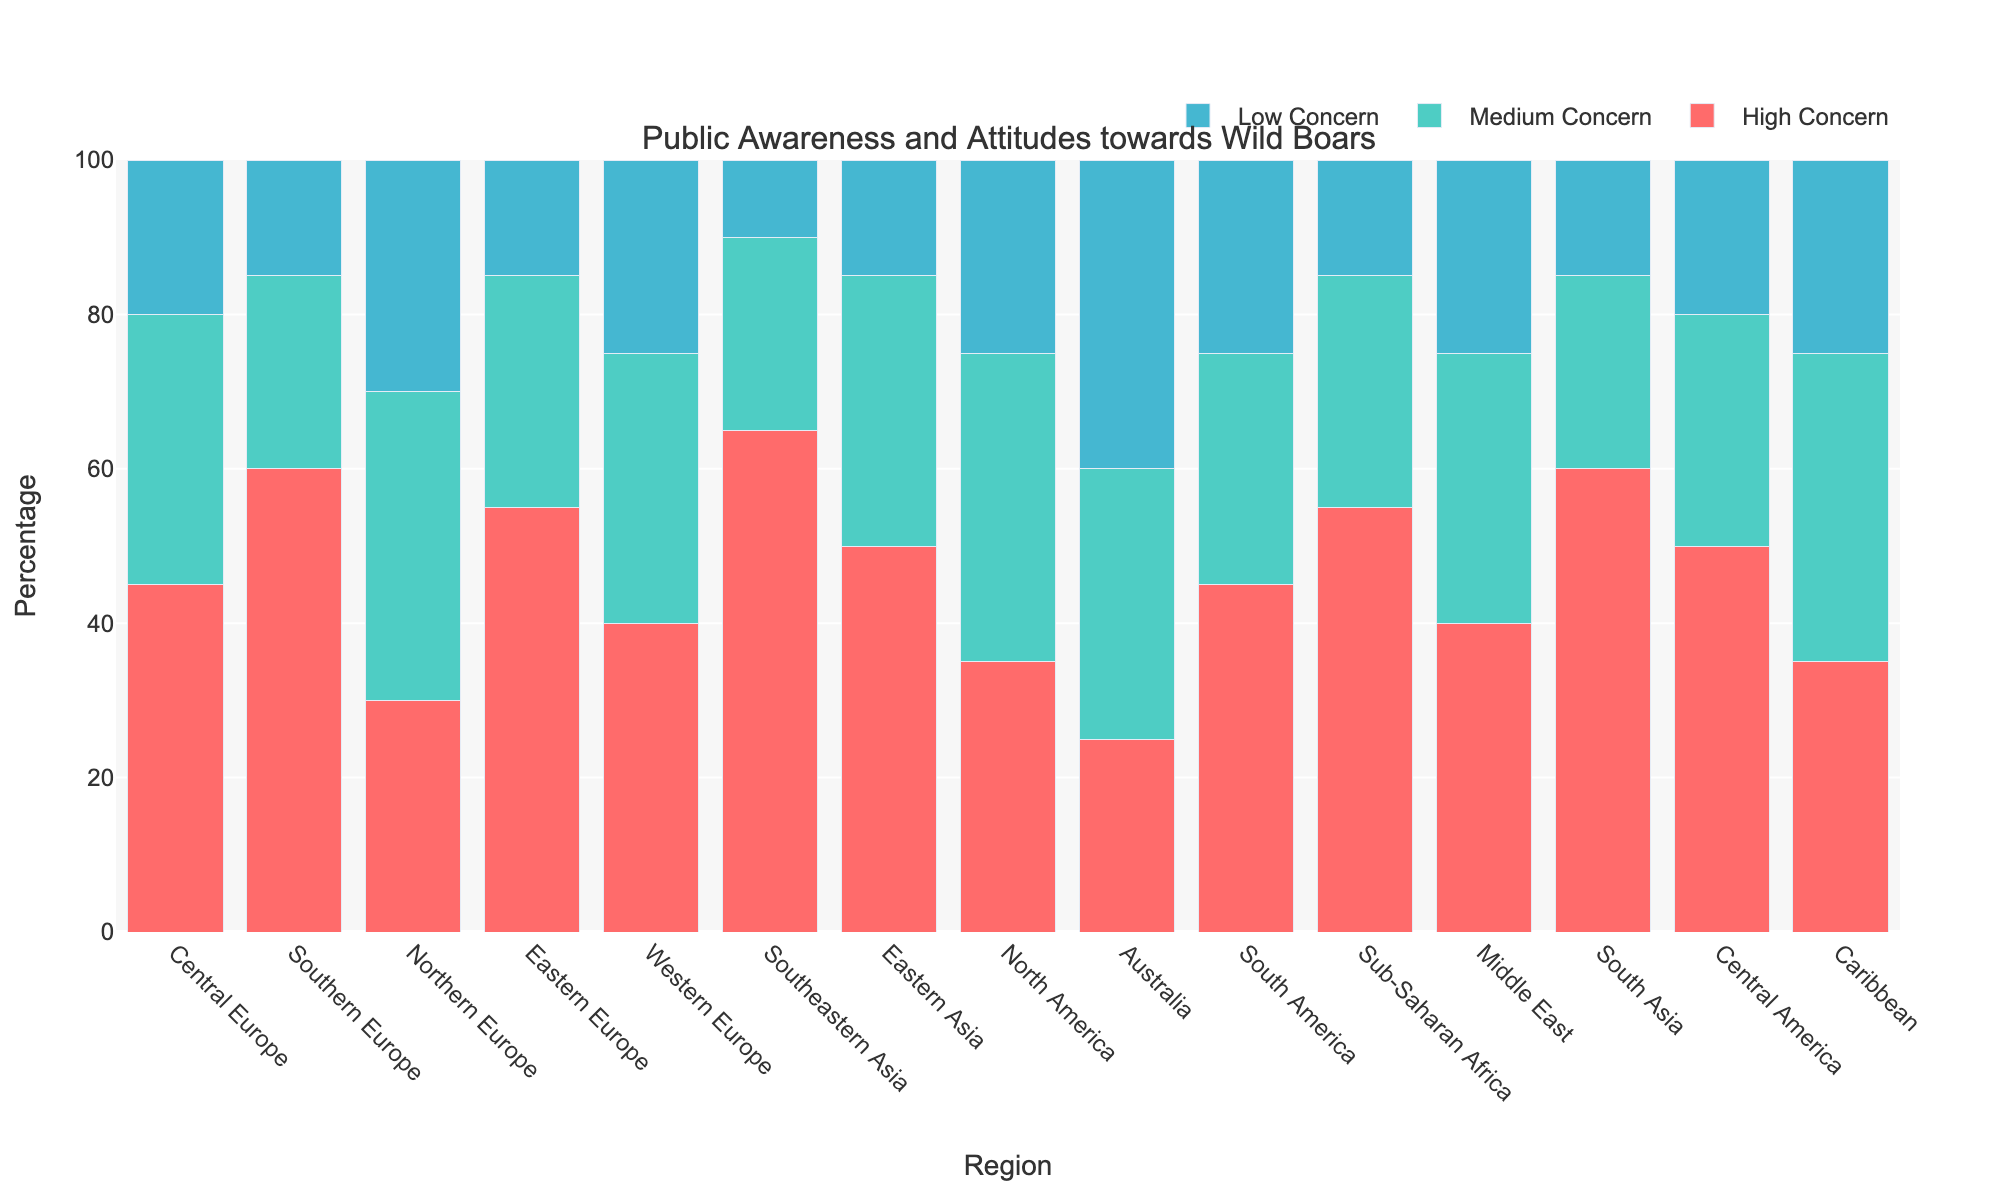What's the region with the highest level of high concern towards wild boars? The "High Concern" bar for Southeastern Asia is the tallest, indicating the highest level of concern.
Answer: Southeastern Asia How do the high concern levels in Southern Europe and Northern Europe compare? By looking at the heights of the bars, Southern Europe has a taller "High Concern" bar than Northern Europe, which indicates a higher concern level.
Answer: Southern Europe has higher concern than Northern Europe What is the combined percentage of medium and low concern in Central America? Add the "Medium Concern" and "Low Concern" values for Central America: 30 + 20 = 50%.
Answer: 50% Which region has the lowest percentage of low concern? The "Low Concern" bar is shortest for Southeastern Asia and South Asia, each at 10%.
Answer: Southeastern Asia and South Asia What is the difference in high concern levels between Eastern Europe and Sub-Saharan Africa? Subtract the "High Concern" value for Sub-Saharan Africa from that of Eastern Europe: 55 - 55 = 0.
Answer: 0 Between Central Europe and Australia, which has a higher combined percentage of medium and low concern? Calculate the sum for both: Central Europe: 35 (Medium) + 20 (Low) = 55; Australia: 35 (Medium) + 40 (Low) = 75. Australia has a higher combined percentage.
Answer: Australia How does the level of high concern in North America compare to that in the Middle East? The "High Concern" bar for North America is at 35%, and for the Middle East, it is at 40%. Therefore, North America has a lower level of high concern.
Answer: Middle East has a higher level of high concern Which regions have an equal level of low concern? From the chart, Northern Europe, North America, Western Europe, and Caribbean all have a 25% "Low Concern" level.
Answer: Northern Europe, North America, Western Europe, and Caribbean What is the average level of medium concern across all regions? Sum all medium concern values and divide by the number of regions: (35+25+40+30+35+25+35+40+35+30+30+35+25+30+40) / 15 = 33.33%.
Answer: 33.33% Which region has the highest overall combined (sum of high, medium, low) concern percentage? Adding up all values for each region, all total to 100%. Therefore, all regions have the same combined concern percentage.
Answer: All regions have the same combined percentage, 100% 